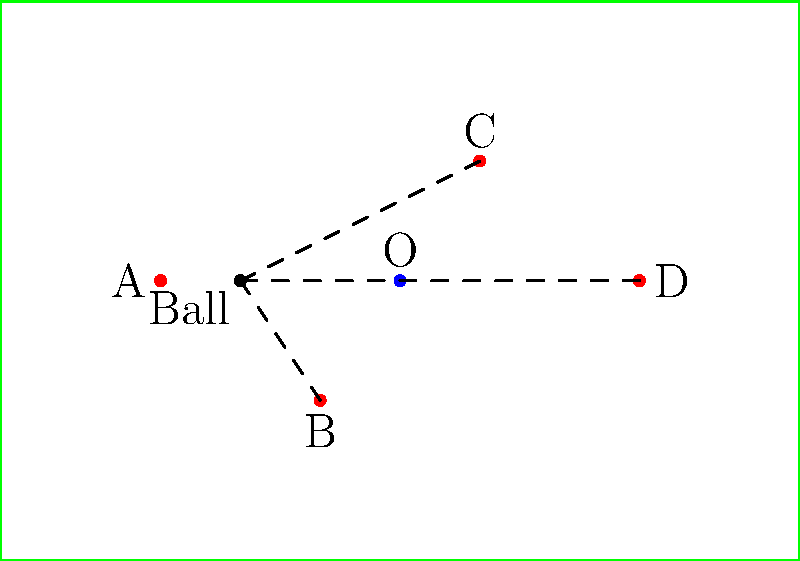In the given top-down view of a soccer field, player A has possession of the ball. Three potential passing lanes to teammates B, C, and D are shown. Considering the position of the opponent O, which passing lane forms the largest angle with respect to the line between player A and the opponent O? Calculate this angle to the nearest degree. To solve this problem, we need to follow these steps:

1) First, we need to establish a coordinate system. Let's assume the bottom-left corner of the field is (0,0) and the top-right is (100,70).

2) We can approximate the positions of the players as follows:
   A: (20,35)
   B: (40,20)
   C: (60,50)
   D: (80,35)
   O: (50,35)

3) We need to calculate the angles between AO and each of AB, AC, and AD.

4) To calculate these angles, we can use the dot product formula:
   $$\cos \theta = \frac{\vec{u} \cdot \vec{v}}{|\vec{u}||\vec{v}|}$$

5) Let's calculate the vectors:
   $\vec{AO} = (30,0)$
   $\vec{AB} = (20,-15)$
   $\vec{AC} = (40,15)$
   $\vec{AD} = (60,0)$

6) Now, let's calculate the angles:

   For AB:
   $$\cos \theta_{AB} = \frac{30 \cdot 20 + 0 \cdot (-15)}{\sqrt{30^2 + 0^2} \sqrt{20^2 + (-15)^2}} = 0.8$$
   $$\theta_{AB} = \arccos(0.8) \approx 36.9°$$

   For AC:
   $$\cos \theta_{AC} = \frac{30 \cdot 40 + 0 \cdot 15}{\sqrt{30^2 + 0^2} \sqrt{40^2 + 15^2}} \approx 0.9363$$
   $$\theta_{AC} = \arccos(0.9363) \approx 20.5°$$

   For AD:
   $$\cos \theta_{AD} = \frac{30 \cdot 60 + 0 \cdot 0}{\sqrt{30^2 + 0^2} \sqrt{60^2 + 0^2}} = 1$$
   $$\theta_{AD} = \arccos(1) = 0°$$

7) The largest angle is between AO and AB, which is approximately 37°.
Answer: 37° 